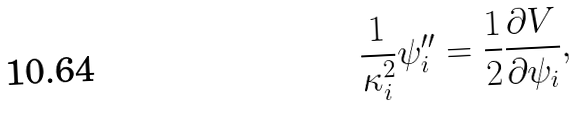Convert formula to latex. <formula><loc_0><loc_0><loc_500><loc_500>\frac { 1 } { \kappa _ { i } ^ { 2 } } \psi _ { i } ^ { \prime \prime } = \frac { 1 } { 2 } \frac { \partial V } { \partial \psi _ { i } } ,</formula> 